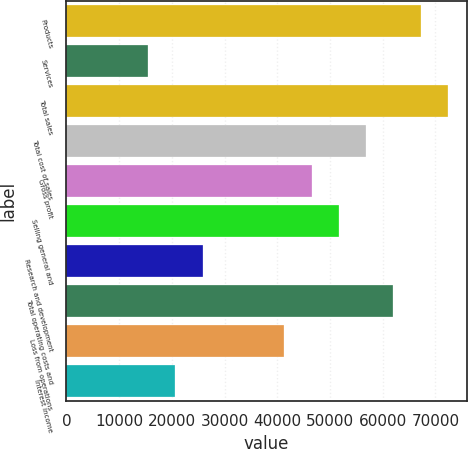Convert chart to OTSL. <chart><loc_0><loc_0><loc_500><loc_500><bar_chart><fcel>Products<fcel>Services<fcel>Total sales<fcel>Total cost of sales<fcel>Gross profit<fcel>Selling general and<fcel>Research and development<fcel>Total operating costs and<fcel>Loss from operations<fcel>Interest income<nl><fcel>67174.7<fcel>15502.6<fcel>72341.9<fcel>56840.2<fcel>46505.8<fcel>51673<fcel>25837<fcel>62007.4<fcel>41338.6<fcel>20669.8<nl></chart> 